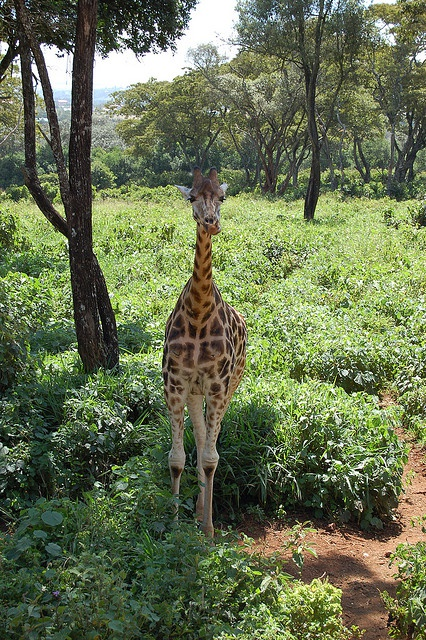Describe the objects in this image and their specific colors. I can see a giraffe in purple, gray, black, and maroon tones in this image. 